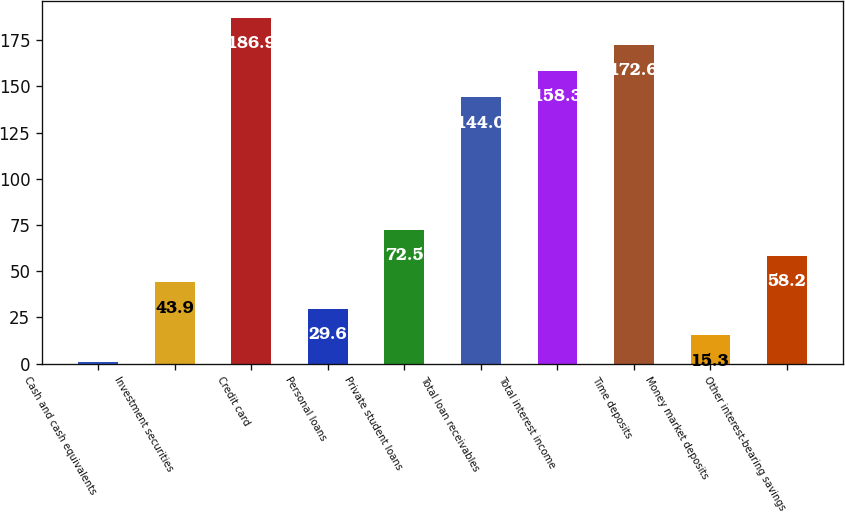Convert chart to OTSL. <chart><loc_0><loc_0><loc_500><loc_500><bar_chart><fcel>Cash and cash equivalents<fcel>Investment securities<fcel>Credit card<fcel>Personal loans<fcel>Private student loans<fcel>Total loan receivables<fcel>Total interest income<fcel>Time deposits<fcel>Money market deposits<fcel>Other interest-bearing savings<nl><fcel>1<fcel>43.9<fcel>186.9<fcel>29.6<fcel>72.5<fcel>144<fcel>158.3<fcel>172.6<fcel>15.3<fcel>58.2<nl></chart> 